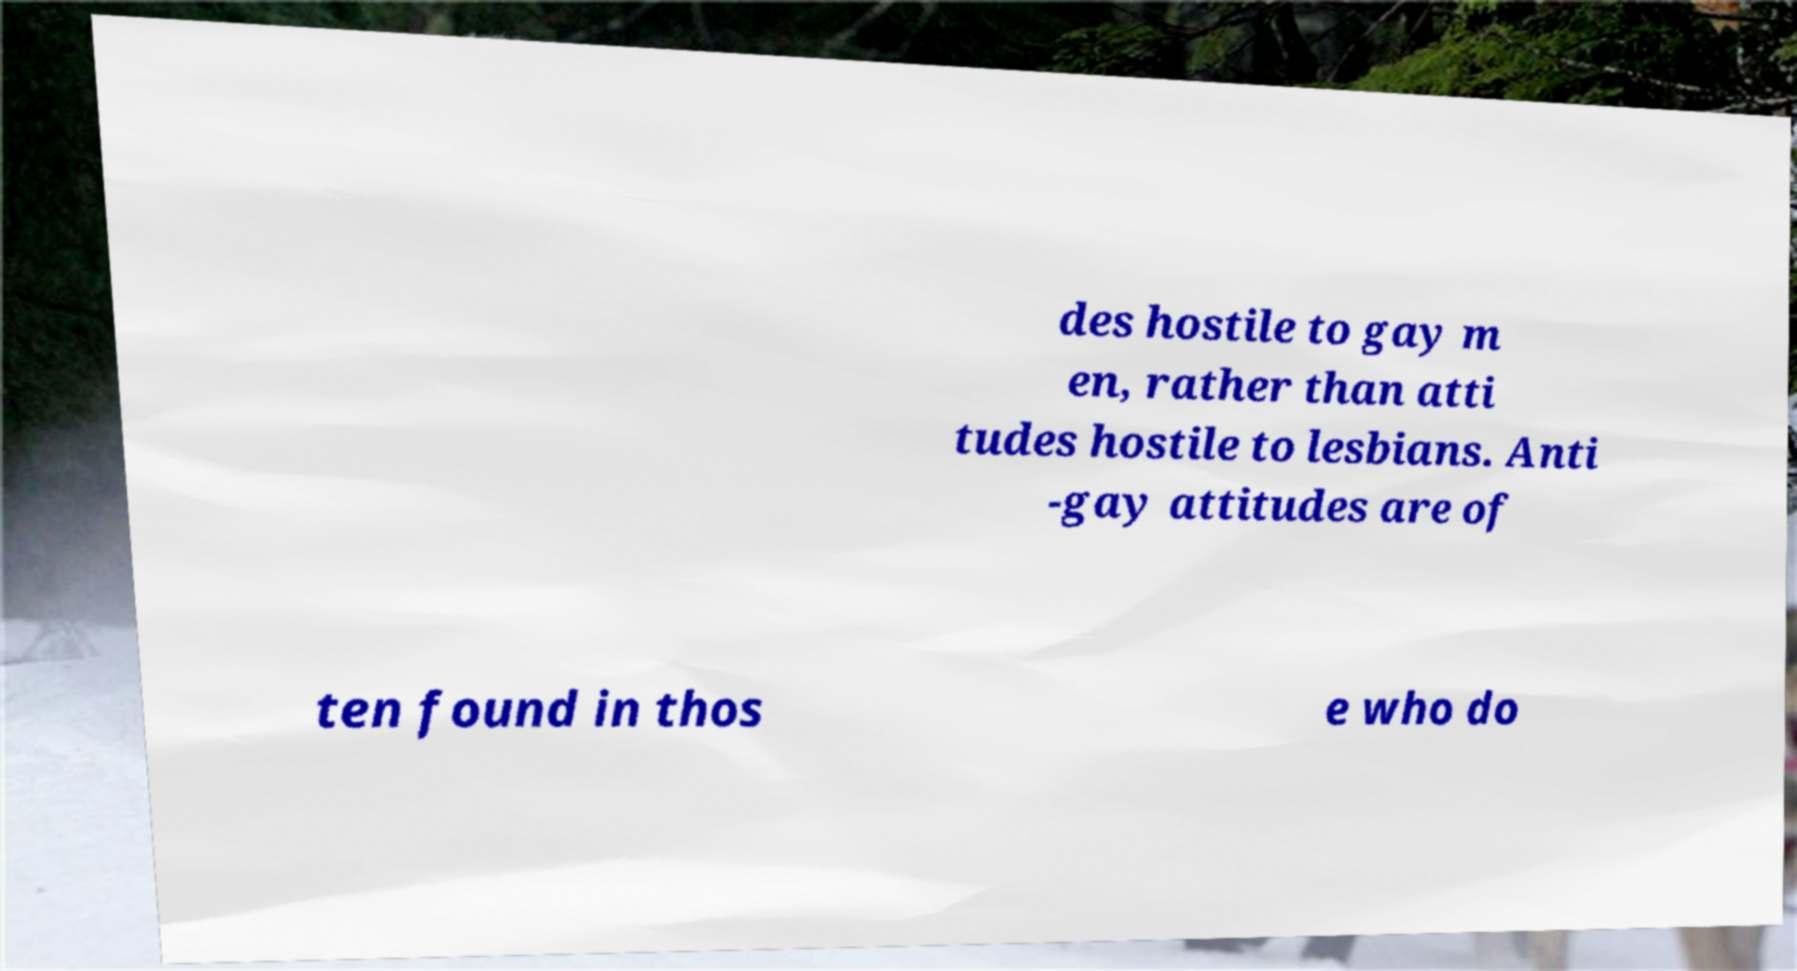For documentation purposes, I need the text within this image transcribed. Could you provide that? des hostile to gay m en, rather than atti tudes hostile to lesbians. Anti -gay attitudes are of ten found in thos e who do 